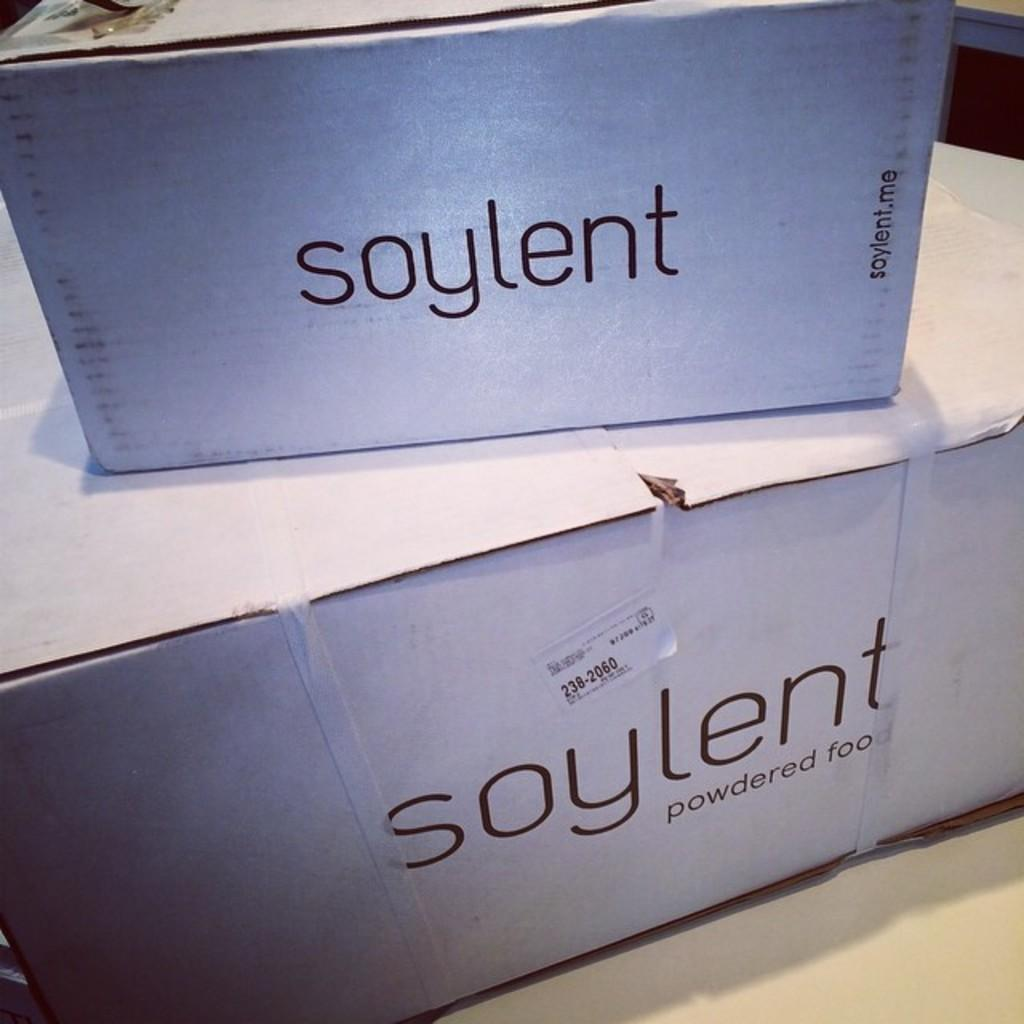<image>
Share a concise interpretation of the image provided. White box that has black lettering soylent powdered foo. 